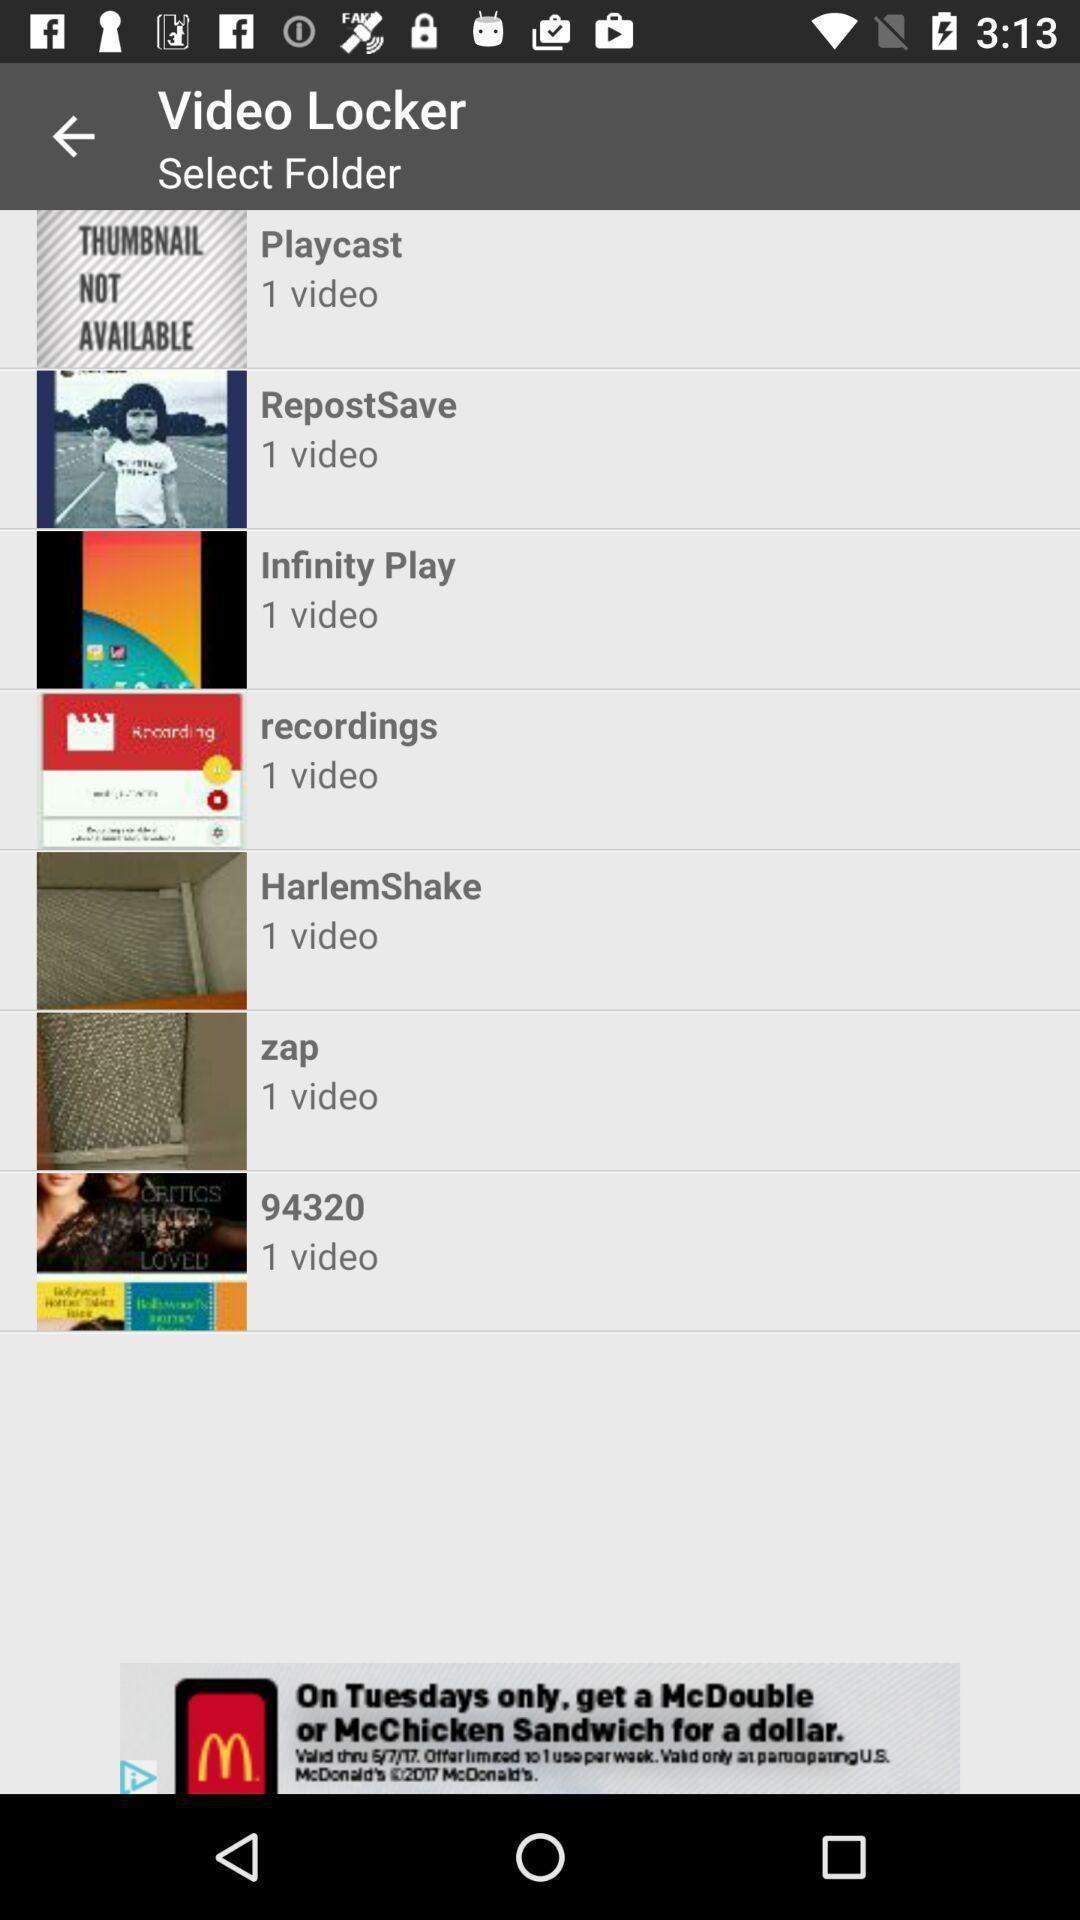Describe the visual elements of this screenshot. Page showing video locker option to lock the videos. 